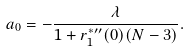Convert formula to latex. <formula><loc_0><loc_0><loc_500><loc_500>a _ { 0 } = - \frac { \lambda } { 1 + r _ { 1 } ^ { * \prime \prime } ( 0 ) ( N - 3 ) } .</formula> 